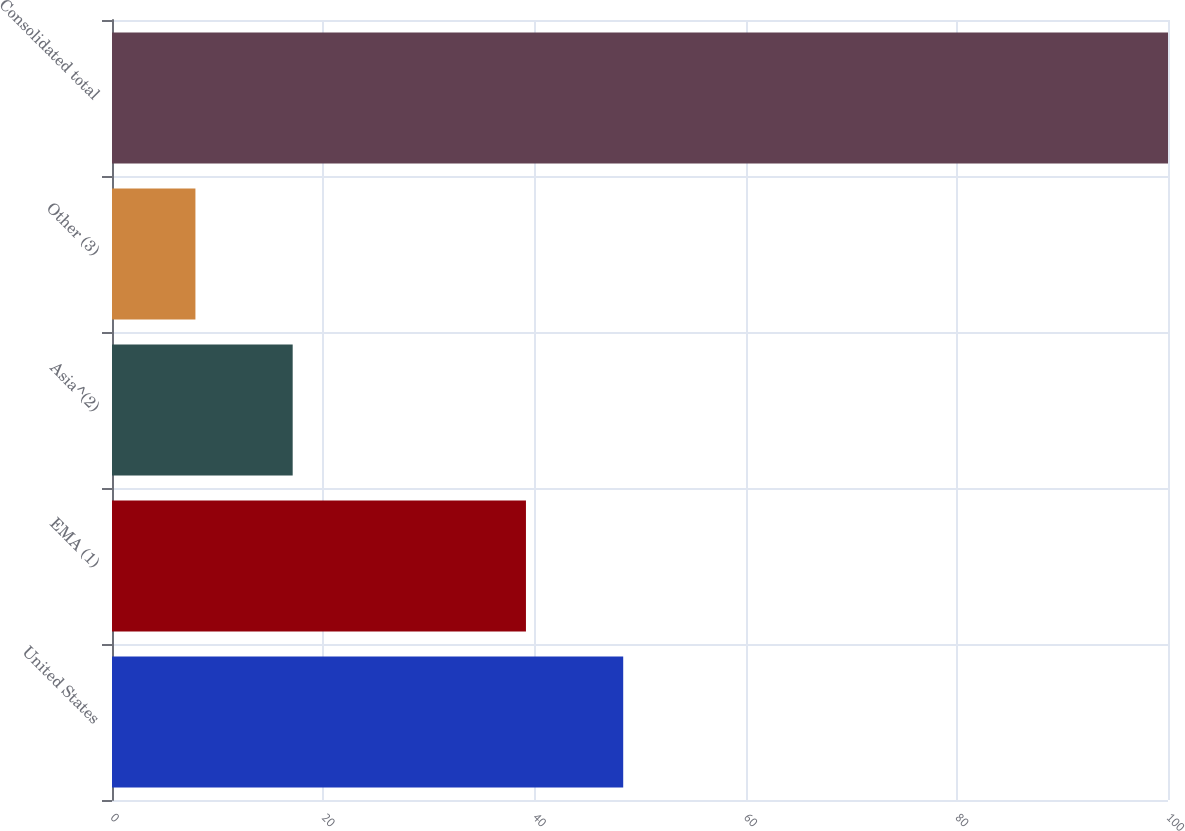Convert chart. <chart><loc_0><loc_0><loc_500><loc_500><bar_chart><fcel>United States<fcel>EMA (1)<fcel>Asia^(2)<fcel>Other (3)<fcel>Consolidated total<nl><fcel>48.41<fcel>39.2<fcel>17.11<fcel>7.9<fcel>100<nl></chart> 